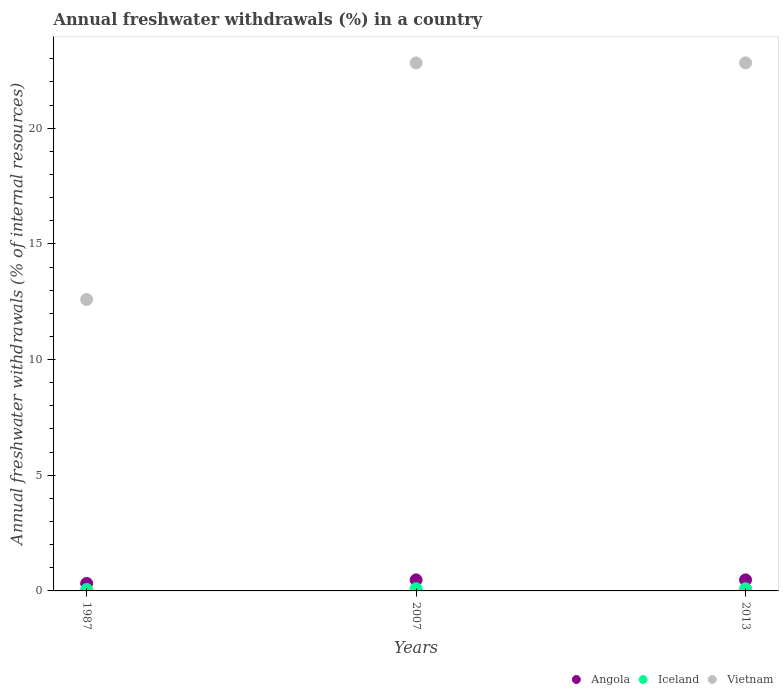What is the percentage of annual freshwater withdrawals in Angola in 2013?
Make the answer very short. 0.48. Across all years, what is the maximum percentage of annual freshwater withdrawals in Iceland?
Keep it short and to the point. 0.1. Across all years, what is the minimum percentage of annual freshwater withdrawals in Angola?
Ensure brevity in your answer.  0.32. In which year was the percentage of annual freshwater withdrawals in Angola maximum?
Offer a very short reply. 2007. What is the total percentage of annual freshwater withdrawals in Angola in the graph?
Offer a terse response. 1.28. What is the difference between the percentage of annual freshwater withdrawals in Iceland in 1987 and that in 2007?
Ensure brevity in your answer.  -0.03. What is the difference between the percentage of annual freshwater withdrawals in Vietnam in 2007 and the percentage of annual freshwater withdrawals in Angola in 1987?
Keep it short and to the point. 22.5. What is the average percentage of annual freshwater withdrawals in Iceland per year?
Provide a short and direct response. 0.09. In the year 1987, what is the difference between the percentage of annual freshwater withdrawals in Angola and percentage of annual freshwater withdrawals in Iceland?
Provide a succinct answer. 0.26. In how many years, is the percentage of annual freshwater withdrawals in Angola greater than 16 %?
Keep it short and to the point. 0. What is the ratio of the percentage of annual freshwater withdrawals in Angola in 1987 to that in 2007?
Offer a terse response. 0.68. Is the percentage of annual freshwater withdrawals in Angola in 1987 less than that in 2007?
Provide a succinct answer. Yes. What is the difference between the highest and the second highest percentage of annual freshwater withdrawals in Iceland?
Provide a succinct answer. 0. What is the difference between the highest and the lowest percentage of annual freshwater withdrawals in Vietnam?
Offer a very short reply. 10.23. Is it the case that in every year, the sum of the percentage of annual freshwater withdrawals in Angola and percentage of annual freshwater withdrawals in Iceland  is greater than the percentage of annual freshwater withdrawals in Vietnam?
Your answer should be very brief. No. Does the percentage of annual freshwater withdrawals in Vietnam monotonically increase over the years?
Your response must be concise. No. Is the percentage of annual freshwater withdrawals in Angola strictly less than the percentage of annual freshwater withdrawals in Iceland over the years?
Ensure brevity in your answer.  No. What is the difference between two consecutive major ticks on the Y-axis?
Give a very brief answer. 5. Are the values on the major ticks of Y-axis written in scientific E-notation?
Offer a very short reply. No. Does the graph contain any zero values?
Provide a succinct answer. No. Does the graph contain grids?
Your answer should be very brief. No. Where does the legend appear in the graph?
Ensure brevity in your answer.  Bottom right. How many legend labels are there?
Your response must be concise. 3. How are the legend labels stacked?
Provide a short and direct response. Horizontal. What is the title of the graph?
Make the answer very short. Annual freshwater withdrawals (%) in a country. What is the label or title of the Y-axis?
Give a very brief answer. Annual freshwater withdrawals (% of internal resources). What is the Annual freshwater withdrawals (% of internal resources) in Angola in 1987?
Make the answer very short. 0.32. What is the Annual freshwater withdrawals (% of internal resources) in Iceland in 1987?
Provide a succinct answer. 0.07. What is the Annual freshwater withdrawals (% of internal resources) in Vietnam in 1987?
Keep it short and to the point. 12.6. What is the Annual freshwater withdrawals (% of internal resources) of Angola in 2007?
Give a very brief answer. 0.48. What is the Annual freshwater withdrawals (% of internal resources) of Iceland in 2007?
Your answer should be very brief. 0.1. What is the Annual freshwater withdrawals (% of internal resources) in Vietnam in 2007?
Make the answer very short. 22.82. What is the Annual freshwater withdrawals (% of internal resources) of Angola in 2013?
Make the answer very short. 0.48. What is the Annual freshwater withdrawals (% of internal resources) in Iceland in 2013?
Your answer should be very brief. 0.1. What is the Annual freshwater withdrawals (% of internal resources) in Vietnam in 2013?
Make the answer very short. 22.82. Across all years, what is the maximum Annual freshwater withdrawals (% of internal resources) in Angola?
Ensure brevity in your answer.  0.48. Across all years, what is the maximum Annual freshwater withdrawals (% of internal resources) of Iceland?
Provide a short and direct response. 0.1. Across all years, what is the maximum Annual freshwater withdrawals (% of internal resources) of Vietnam?
Provide a succinct answer. 22.82. Across all years, what is the minimum Annual freshwater withdrawals (% of internal resources) of Angola?
Your response must be concise. 0.32. Across all years, what is the minimum Annual freshwater withdrawals (% of internal resources) in Iceland?
Ensure brevity in your answer.  0.07. Across all years, what is the minimum Annual freshwater withdrawals (% of internal resources) in Vietnam?
Your answer should be compact. 12.6. What is the total Annual freshwater withdrawals (% of internal resources) in Angola in the graph?
Offer a terse response. 1.28. What is the total Annual freshwater withdrawals (% of internal resources) in Iceland in the graph?
Give a very brief answer. 0.26. What is the total Annual freshwater withdrawals (% of internal resources) in Vietnam in the graph?
Provide a short and direct response. 58.24. What is the difference between the Annual freshwater withdrawals (% of internal resources) in Angola in 1987 and that in 2007?
Provide a short and direct response. -0.15. What is the difference between the Annual freshwater withdrawals (% of internal resources) of Iceland in 1987 and that in 2007?
Your response must be concise. -0.03. What is the difference between the Annual freshwater withdrawals (% of internal resources) of Vietnam in 1987 and that in 2007?
Your answer should be very brief. -10.23. What is the difference between the Annual freshwater withdrawals (% of internal resources) of Angola in 1987 and that in 2013?
Ensure brevity in your answer.  -0.15. What is the difference between the Annual freshwater withdrawals (% of internal resources) of Iceland in 1987 and that in 2013?
Offer a terse response. -0.03. What is the difference between the Annual freshwater withdrawals (% of internal resources) of Vietnam in 1987 and that in 2013?
Your answer should be very brief. -10.23. What is the difference between the Annual freshwater withdrawals (% of internal resources) of Angola in 2007 and that in 2013?
Offer a terse response. 0. What is the difference between the Annual freshwater withdrawals (% of internal resources) in Vietnam in 2007 and that in 2013?
Ensure brevity in your answer.  0. What is the difference between the Annual freshwater withdrawals (% of internal resources) in Angola in 1987 and the Annual freshwater withdrawals (% of internal resources) in Iceland in 2007?
Provide a succinct answer. 0.23. What is the difference between the Annual freshwater withdrawals (% of internal resources) in Angola in 1987 and the Annual freshwater withdrawals (% of internal resources) in Vietnam in 2007?
Offer a terse response. -22.5. What is the difference between the Annual freshwater withdrawals (% of internal resources) in Iceland in 1987 and the Annual freshwater withdrawals (% of internal resources) in Vietnam in 2007?
Provide a short and direct response. -22.76. What is the difference between the Annual freshwater withdrawals (% of internal resources) in Angola in 1987 and the Annual freshwater withdrawals (% of internal resources) in Iceland in 2013?
Your response must be concise. 0.23. What is the difference between the Annual freshwater withdrawals (% of internal resources) of Angola in 1987 and the Annual freshwater withdrawals (% of internal resources) of Vietnam in 2013?
Keep it short and to the point. -22.5. What is the difference between the Annual freshwater withdrawals (% of internal resources) in Iceland in 1987 and the Annual freshwater withdrawals (% of internal resources) in Vietnam in 2013?
Offer a very short reply. -22.76. What is the difference between the Annual freshwater withdrawals (% of internal resources) of Angola in 2007 and the Annual freshwater withdrawals (% of internal resources) of Iceland in 2013?
Provide a short and direct response. 0.38. What is the difference between the Annual freshwater withdrawals (% of internal resources) of Angola in 2007 and the Annual freshwater withdrawals (% of internal resources) of Vietnam in 2013?
Give a very brief answer. -22.35. What is the difference between the Annual freshwater withdrawals (% of internal resources) in Iceland in 2007 and the Annual freshwater withdrawals (% of internal resources) in Vietnam in 2013?
Your answer should be compact. -22.73. What is the average Annual freshwater withdrawals (% of internal resources) of Angola per year?
Offer a terse response. 0.43. What is the average Annual freshwater withdrawals (% of internal resources) of Iceland per year?
Offer a terse response. 0.09. What is the average Annual freshwater withdrawals (% of internal resources) of Vietnam per year?
Give a very brief answer. 19.41. In the year 1987, what is the difference between the Annual freshwater withdrawals (% of internal resources) in Angola and Annual freshwater withdrawals (% of internal resources) in Iceland?
Your response must be concise. 0.26. In the year 1987, what is the difference between the Annual freshwater withdrawals (% of internal resources) in Angola and Annual freshwater withdrawals (% of internal resources) in Vietnam?
Keep it short and to the point. -12.27. In the year 1987, what is the difference between the Annual freshwater withdrawals (% of internal resources) in Iceland and Annual freshwater withdrawals (% of internal resources) in Vietnam?
Offer a terse response. -12.53. In the year 2007, what is the difference between the Annual freshwater withdrawals (% of internal resources) of Angola and Annual freshwater withdrawals (% of internal resources) of Iceland?
Ensure brevity in your answer.  0.38. In the year 2007, what is the difference between the Annual freshwater withdrawals (% of internal resources) of Angola and Annual freshwater withdrawals (% of internal resources) of Vietnam?
Offer a terse response. -22.35. In the year 2007, what is the difference between the Annual freshwater withdrawals (% of internal resources) in Iceland and Annual freshwater withdrawals (% of internal resources) in Vietnam?
Provide a short and direct response. -22.73. In the year 2013, what is the difference between the Annual freshwater withdrawals (% of internal resources) of Angola and Annual freshwater withdrawals (% of internal resources) of Iceland?
Make the answer very short. 0.38. In the year 2013, what is the difference between the Annual freshwater withdrawals (% of internal resources) of Angola and Annual freshwater withdrawals (% of internal resources) of Vietnam?
Offer a very short reply. -22.35. In the year 2013, what is the difference between the Annual freshwater withdrawals (% of internal resources) of Iceland and Annual freshwater withdrawals (% of internal resources) of Vietnam?
Your answer should be very brief. -22.73. What is the ratio of the Annual freshwater withdrawals (% of internal resources) in Angola in 1987 to that in 2007?
Make the answer very short. 0.68. What is the ratio of the Annual freshwater withdrawals (% of internal resources) of Iceland in 1987 to that in 2007?
Your answer should be very brief. 0.68. What is the ratio of the Annual freshwater withdrawals (% of internal resources) of Vietnam in 1987 to that in 2007?
Keep it short and to the point. 0.55. What is the ratio of the Annual freshwater withdrawals (% of internal resources) in Angola in 1987 to that in 2013?
Your answer should be very brief. 0.68. What is the ratio of the Annual freshwater withdrawals (% of internal resources) of Iceland in 1987 to that in 2013?
Your response must be concise. 0.68. What is the ratio of the Annual freshwater withdrawals (% of internal resources) of Vietnam in 1987 to that in 2013?
Make the answer very short. 0.55. What is the ratio of the Annual freshwater withdrawals (% of internal resources) of Angola in 2007 to that in 2013?
Ensure brevity in your answer.  1. What is the ratio of the Annual freshwater withdrawals (% of internal resources) of Iceland in 2007 to that in 2013?
Offer a very short reply. 1. What is the difference between the highest and the second highest Annual freshwater withdrawals (% of internal resources) in Iceland?
Your response must be concise. 0. What is the difference between the highest and the lowest Annual freshwater withdrawals (% of internal resources) of Angola?
Make the answer very short. 0.15. What is the difference between the highest and the lowest Annual freshwater withdrawals (% of internal resources) in Iceland?
Give a very brief answer. 0.03. What is the difference between the highest and the lowest Annual freshwater withdrawals (% of internal resources) in Vietnam?
Provide a succinct answer. 10.23. 